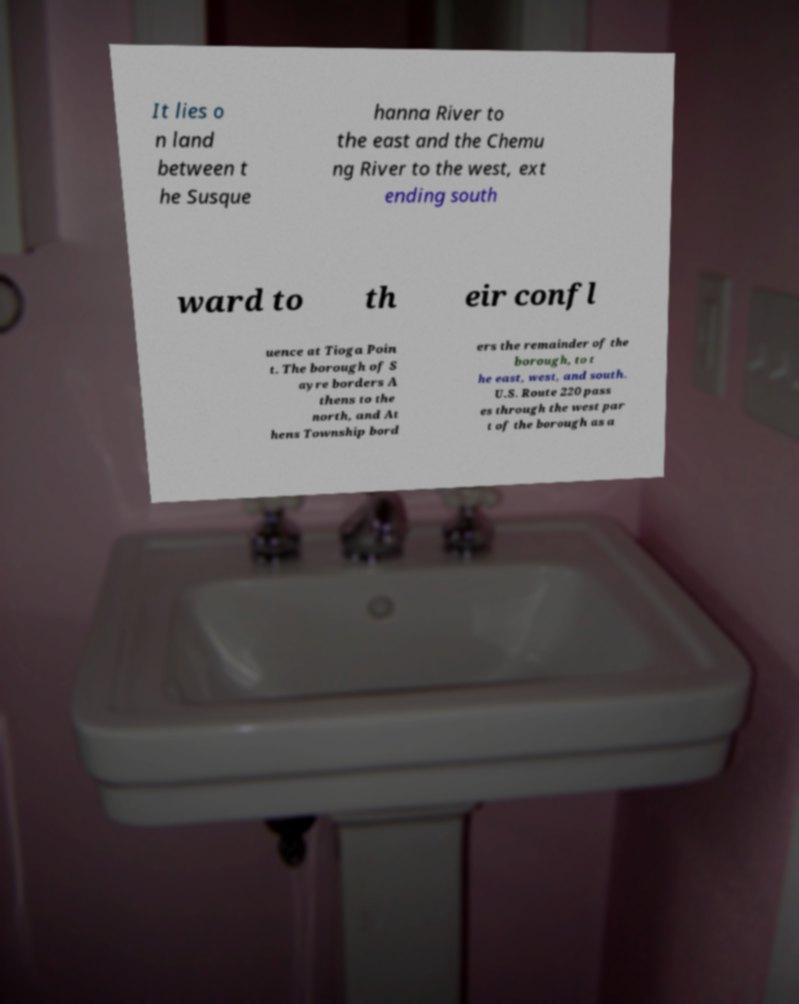Can you read and provide the text displayed in the image?This photo seems to have some interesting text. Can you extract and type it out for me? It lies o n land between t he Susque hanna River to the east and the Chemu ng River to the west, ext ending south ward to th eir confl uence at Tioga Poin t. The borough of S ayre borders A thens to the north, and At hens Township bord ers the remainder of the borough, to t he east, west, and south. U.S. Route 220 pass es through the west par t of the borough as a 